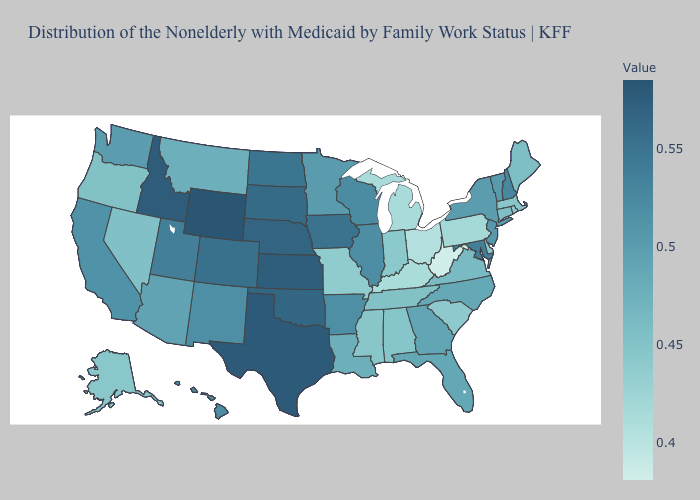Does Texas have the highest value in the South?
Keep it brief. Yes. Does California have the highest value in the USA?
Give a very brief answer. No. Does Kansas have the highest value in the MidWest?
Keep it brief. Yes. Which states have the lowest value in the Northeast?
Answer briefly. Pennsylvania. Does Alaska have the lowest value in the West?
Give a very brief answer. Yes. Among the states that border Oregon , which have the lowest value?
Keep it brief. Nevada. 